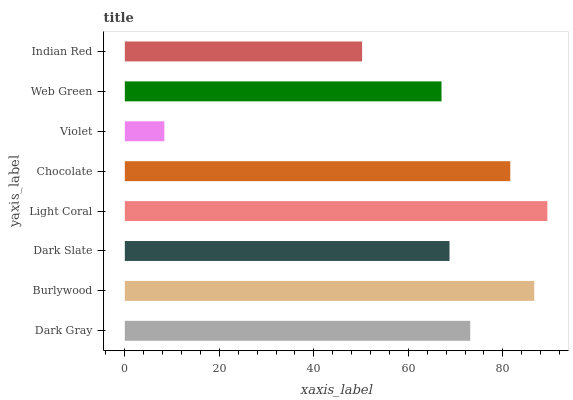Is Violet the minimum?
Answer yes or no. Yes. Is Light Coral the maximum?
Answer yes or no. Yes. Is Burlywood the minimum?
Answer yes or no. No. Is Burlywood the maximum?
Answer yes or no. No. Is Burlywood greater than Dark Gray?
Answer yes or no. Yes. Is Dark Gray less than Burlywood?
Answer yes or no. Yes. Is Dark Gray greater than Burlywood?
Answer yes or no. No. Is Burlywood less than Dark Gray?
Answer yes or no. No. Is Dark Gray the high median?
Answer yes or no. Yes. Is Dark Slate the low median?
Answer yes or no. Yes. Is Indian Red the high median?
Answer yes or no. No. Is Chocolate the low median?
Answer yes or no. No. 